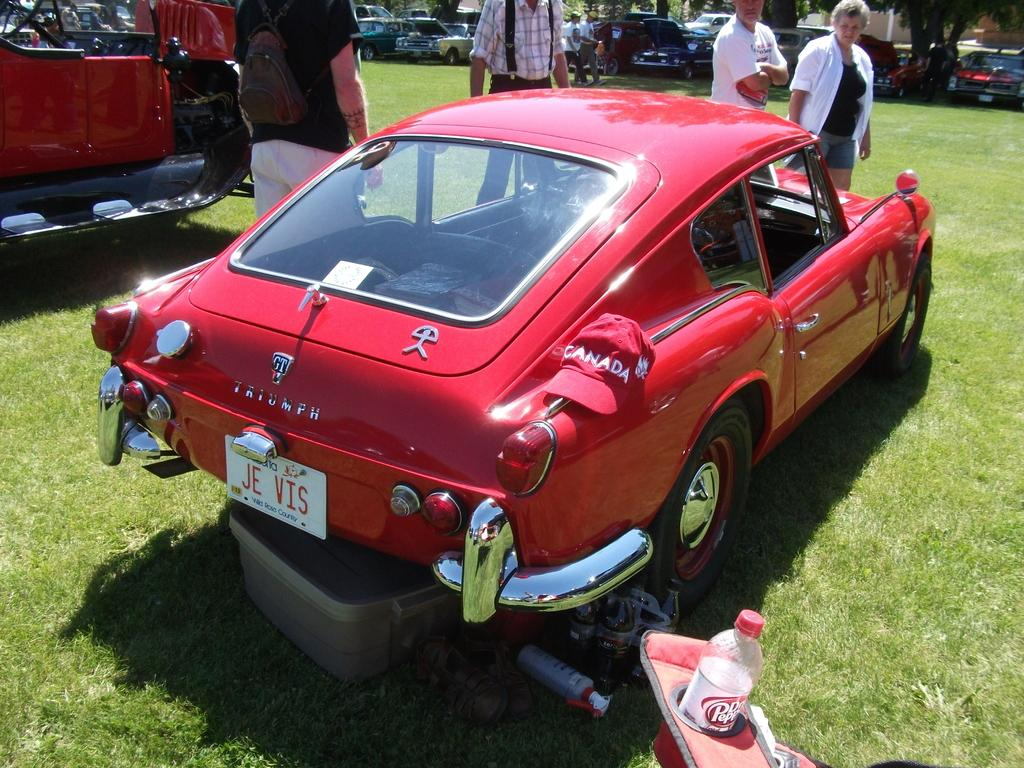What types of vehicles are present in the image? There are different cars in the image. How are the cars positioned in the image? The cars are kept on the ground. What can be seen in front of the first car? There are people standing in front of the first car. What is located beside the first car on the grass? There are objects kept on the grass beside the first car. What type of plastic is covering the clover on the grass beside the first car? There is no plastic or clover mentioned in the image; it only describes cars, people, and objects. 